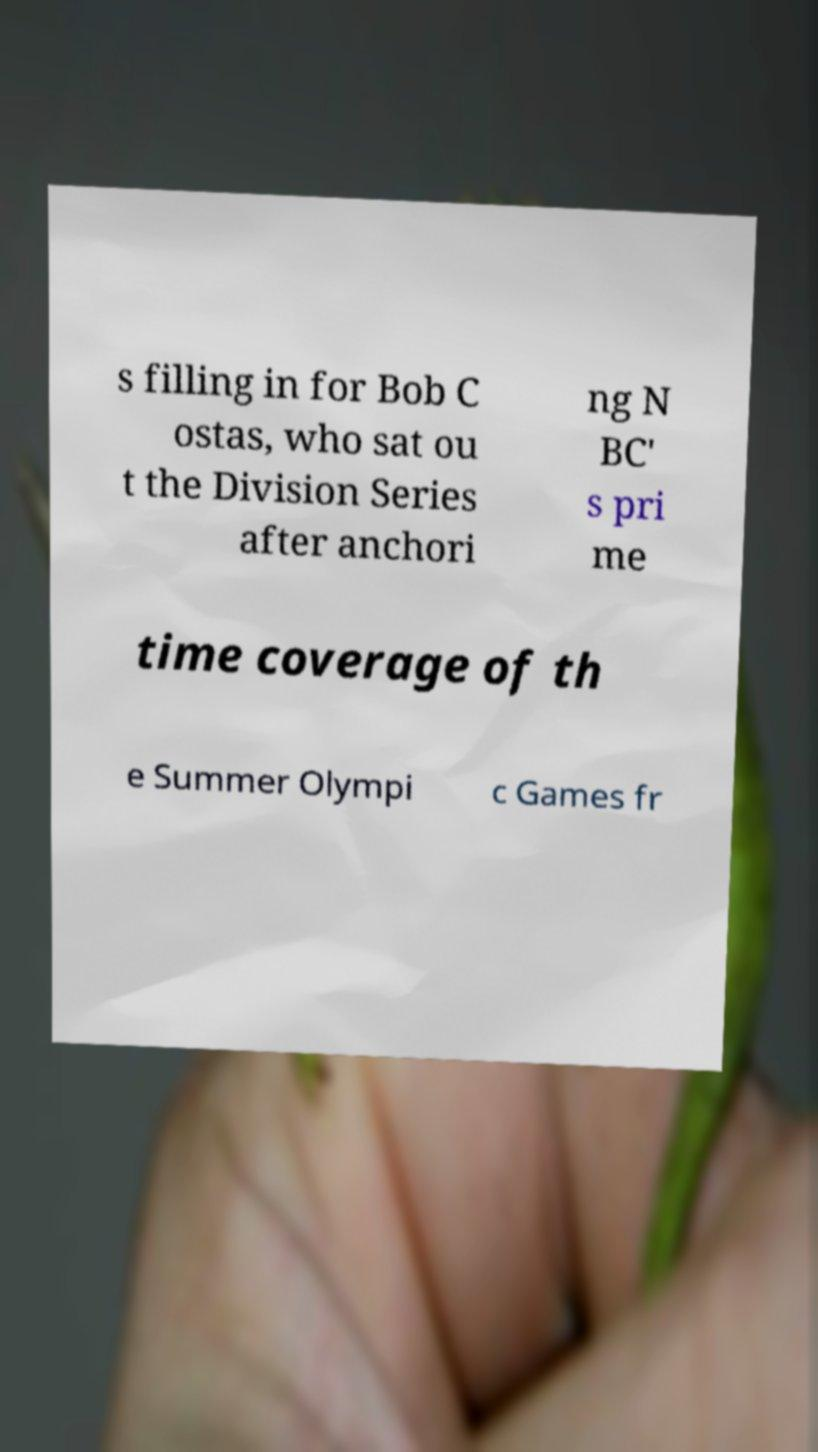What messages or text are displayed in this image? I need them in a readable, typed format. s filling in for Bob C ostas, who sat ou t the Division Series after anchori ng N BC' s pri me time coverage of th e Summer Olympi c Games fr 